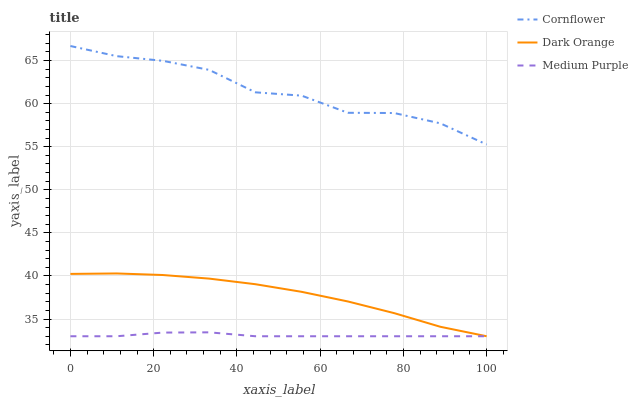Does Medium Purple have the minimum area under the curve?
Answer yes or no. Yes. Does Cornflower have the maximum area under the curve?
Answer yes or no. Yes. Does Dark Orange have the minimum area under the curve?
Answer yes or no. No. Does Dark Orange have the maximum area under the curve?
Answer yes or no. No. Is Medium Purple the smoothest?
Answer yes or no. Yes. Is Cornflower the roughest?
Answer yes or no. Yes. Is Dark Orange the smoothest?
Answer yes or no. No. Is Dark Orange the roughest?
Answer yes or no. No. Does Medium Purple have the lowest value?
Answer yes or no. Yes. Does Cornflower have the lowest value?
Answer yes or no. No. Does Cornflower have the highest value?
Answer yes or no. Yes. Does Dark Orange have the highest value?
Answer yes or no. No. Is Medium Purple less than Cornflower?
Answer yes or no. Yes. Is Cornflower greater than Medium Purple?
Answer yes or no. Yes. Does Medium Purple intersect Dark Orange?
Answer yes or no. Yes. Is Medium Purple less than Dark Orange?
Answer yes or no. No. Is Medium Purple greater than Dark Orange?
Answer yes or no. No. Does Medium Purple intersect Cornflower?
Answer yes or no. No. 